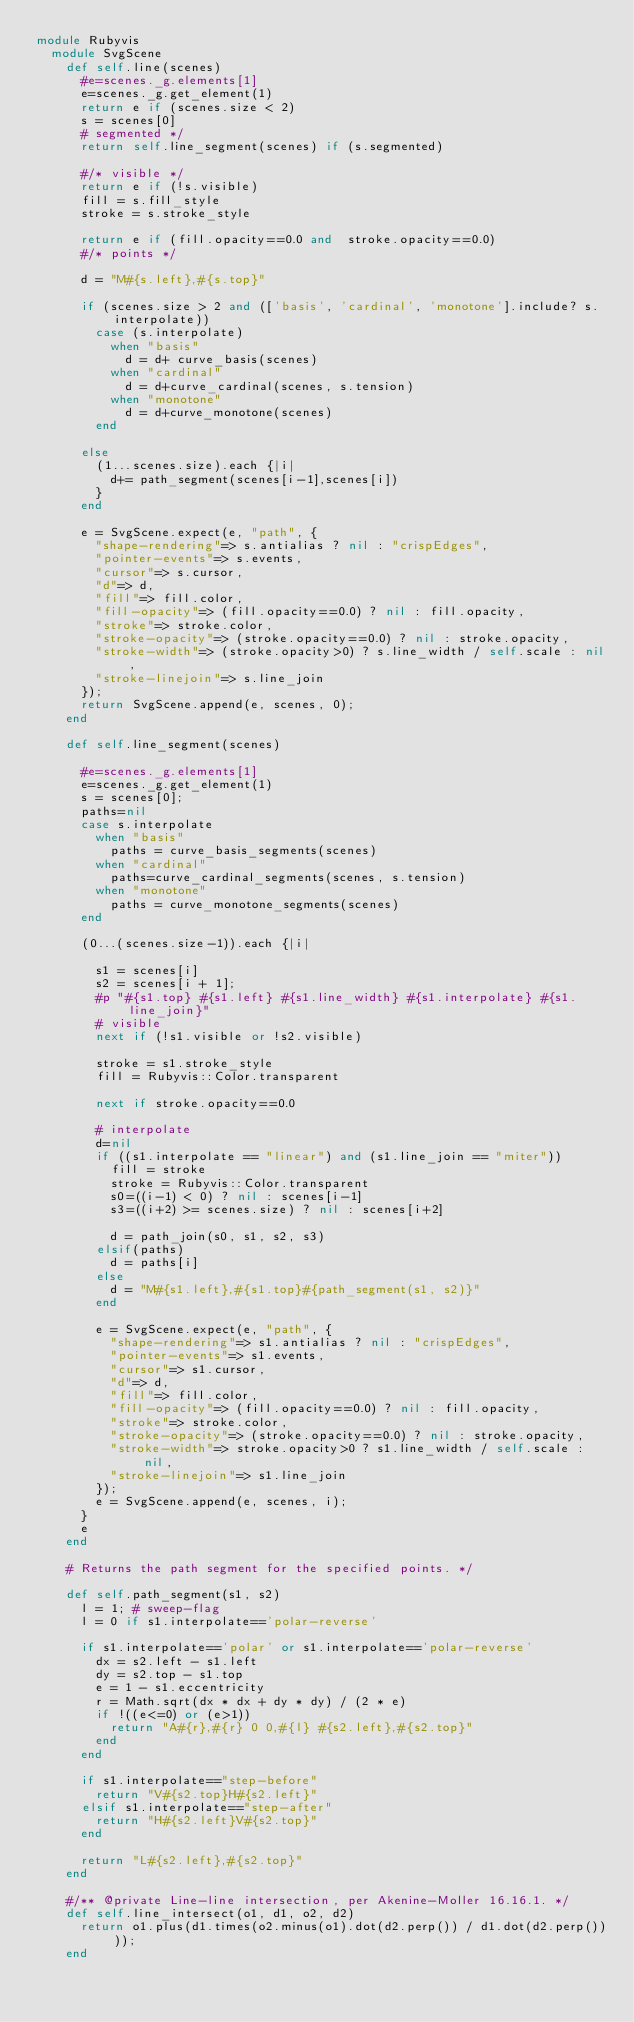Convert code to text. <code><loc_0><loc_0><loc_500><loc_500><_Ruby_>module Rubyvis
  module SvgScene
    def self.line(scenes)
      #e=scenes._g.elements[1]
      e=scenes._g.get_element(1)
      return e if (scenes.size < 2)
      s = scenes[0]
      # segmented */
      return self.line_segment(scenes) if (s.segmented)

      #/* visible */
      return e if (!s.visible)
      fill = s.fill_style
      stroke = s.stroke_style

      return e if (fill.opacity==0.0 and  stroke.opacity==0.0)
      #/* points */

      d = "M#{s.left},#{s.top}"

      if (scenes.size > 2 and (['basis', 'cardinal', 'monotone'].include? s.interpolate))
        case (s.interpolate)
          when "basis"
            d = d+ curve_basis(scenes)
          when "cardinal"
            d = d+curve_cardinal(scenes, s.tension)
          when "monotone"
            d = d+curve_monotone(scenes)
        end

      else
        (1...scenes.size).each {|i|
          d+= path_segment(scenes[i-1],scenes[i])
        }
      end

      e = SvgScene.expect(e, "path", {
        "shape-rendering"=> s.antialias ? nil : "crispEdges",
        "pointer-events"=> s.events,
        "cursor"=> s.cursor,
        "d"=> d,
        "fill"=> fill.color,
        "fill-opacity"=> (fill.opacity==0.0) ? nil : fill.opacity,
        "stroke"=> stroke.color,
        "stroke-opacity"=> (stroke.opacity==0.0) ? nil : stroke.opacity,
        "stroke-width"=> (stroke.opacity>0) ? s.line_width / self.scale : nil,
        "stroke-linejoin"=> s.line_join
      });
      return SvgScene.append(e, scenes, 0);
    end

    def self.line_segment(scenes)

      #e=scenes._g.elements[1]
      e=scenes._g.get_element(1)
      s = scenes[0];
      paths=nil
      case s.interpolate
        when "basis"
          paths = curve_basis_segments(scenes)
        when "cardinal"
          paths=curve_cardinal_segments(scenes, s.tension)
        when "monotone"
          paths = curve_monotone_segments(scenes)
      end

      (0...(scenes.size-1)).each {|i|

        s1 = scenes[i]
        s2 = scenes[i + 1];
        #p "#{s1.top} #{s1.left} #{s1.line_width} #{s1.interpolate} #{s1.line_join}"
        # visible 
        next if (!s1.visible or !s2.visible)

        stroke = s1.stroke_style
        fill = Rubyvis::Color.transparent

        next if stroke.opacity==0.0

        # interpolate
        d=nil
        if ((s1.interpolate == "linear") and (s1.line_join == "miter"))
          fill = stroke
          stroke = Rubyvis::Color.transparent
          s0=((i-1) < 0) ? nil : scenes[i-1]
          s3=((i+2) >= scenes.size) ? nil : scenes[i+2]
          
          d = path_join(s0, s1, s2, s3)
        elsif(paths)
          d = paths[i]
        else
          d = "M#{s1.left},#{s1.top}#{path_segment(s1, s2)}"
        end

        e = SvgScene.expect(e, "path", {
          "shape-rendering"=> s1.antialias ? nil : "crispEdges",
          "pointer-events"=> s1.events,
          "cursor"=> s1.cursor,
          "d"=> d,
          "fill"=> fill.color,
          "fill-opacity"=> (fill.opacity==0.0) ? nil : fill.opacity,
          "stroke"=> stroke.color,
          "stroke-opacity"=> (stroke.opacity==0.0) ? nil : stroke.opacity,
          "stroke-width"=> stroke.opacity>0 ? s1.line_width / self.scale : nil,
          "stroke-linejoin"=> s1.line_join
        });
        e = SvgScene.append(e, scenes, i);
      }
      e
    end

    # Returns the path segment for the specified points. */

    def self.path_segment(s1, s2) 
      l = 1; # sweep-flag
      l = 0 if s1.interpolate=='polar-reverse'
      
      if s1.interpolate=='polar' or s1.interpolate=='polar-reverse'
        dx = s2.left - s1.left
        dy = s2.top - s1.top
        e = 1 - s1.eccentricity
        r = Math.sqrt(dx * dx + dy * dy) / (2 * e)
        if !((e<=0) or (e>1))
          return "A#{r},#{r} 0 0,#{l} #{s2.left},#{s2.top}"
        end
      end
      
      if s1.interpolate=="step-before"
        return "V#{s2.top}H#{s2.left}"
      elsif s1.interpolate=="step-after"
        return "H#{s2.left}V#{s2.top}"
      end
      
      return "L#{s2.left},#{s2.top}"
    end

    #/** @private Line-line intersection, per Akenine-Moller 16.16.1. */
    def self.line_intersect(o1, d1, o2, d2)
      return o1.plus(d1.times(o2.minus(o1).dot(d2.perp()) / d1.dot(d2.perp())));
    end
</code> 